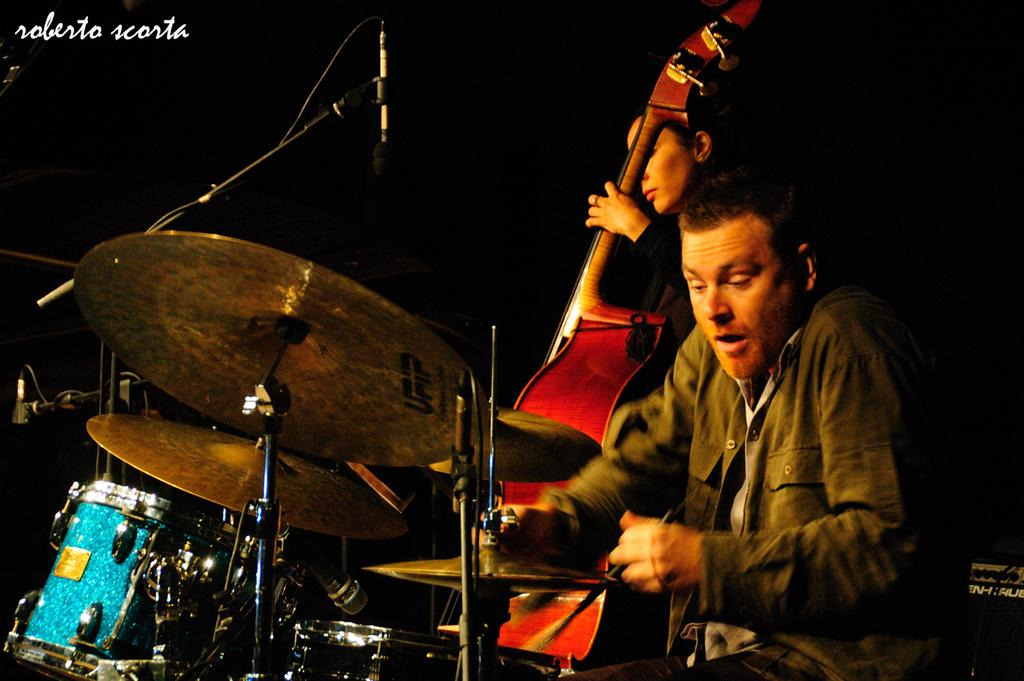What instruments are being played by the people in the image? A person is playing drums, and another person is playing guitar. Can you describe the position of the microphone in the image? There is a microphone at the left back of the image. Are there any mice running around on the drums in the image? There are no mice present in the image; the focus is on the people playing instruments. Is the person playing guitar driving a car in the image? There is no car or driving activity depicted in the image; it features people playing musical instruments. 